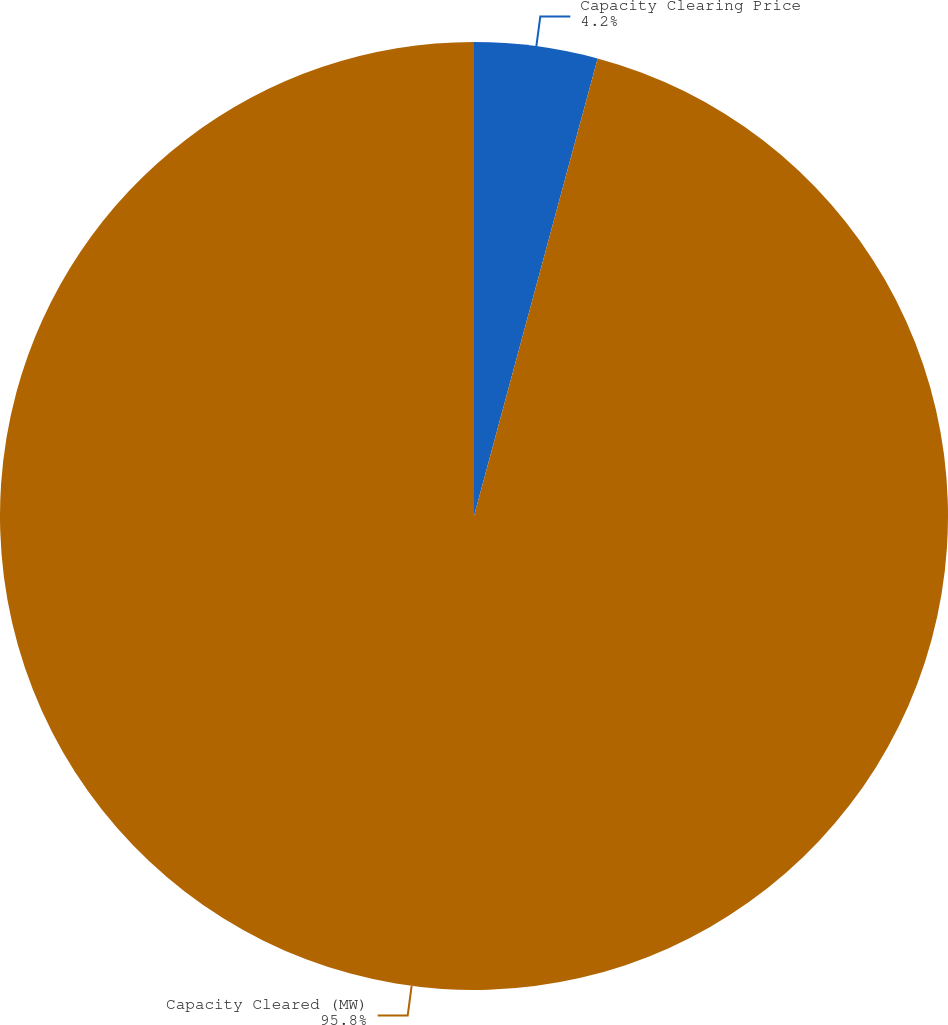Convert chart to OTSL. <chart><loc_0><loc_0><loc_500><loc_500><pie_chart><fcel>Capacity Clearing Price<fcel>Capacity Cleared (MW)<nl><fcel>4.2%<fcel>95.8%<nl></chart> 